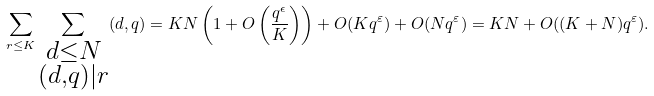<formula> <loc_0><loc_0><loc_500><loc_500>\sum _ { r \leq K } \sum _ { \substack { d \leq N \\ ( d , q ) | r } } ( d , q ) = K N \left ( 1 + O \left ( \frac { q ^ { \epsilon } } { K } \right ) \right ) + O ( K q ^ { \varepsilon } ) + O ( N q ^ { \varepsilon } ) = K N + O ( ( K + N ) q ^ { \varepsilon } ) .</formula> 